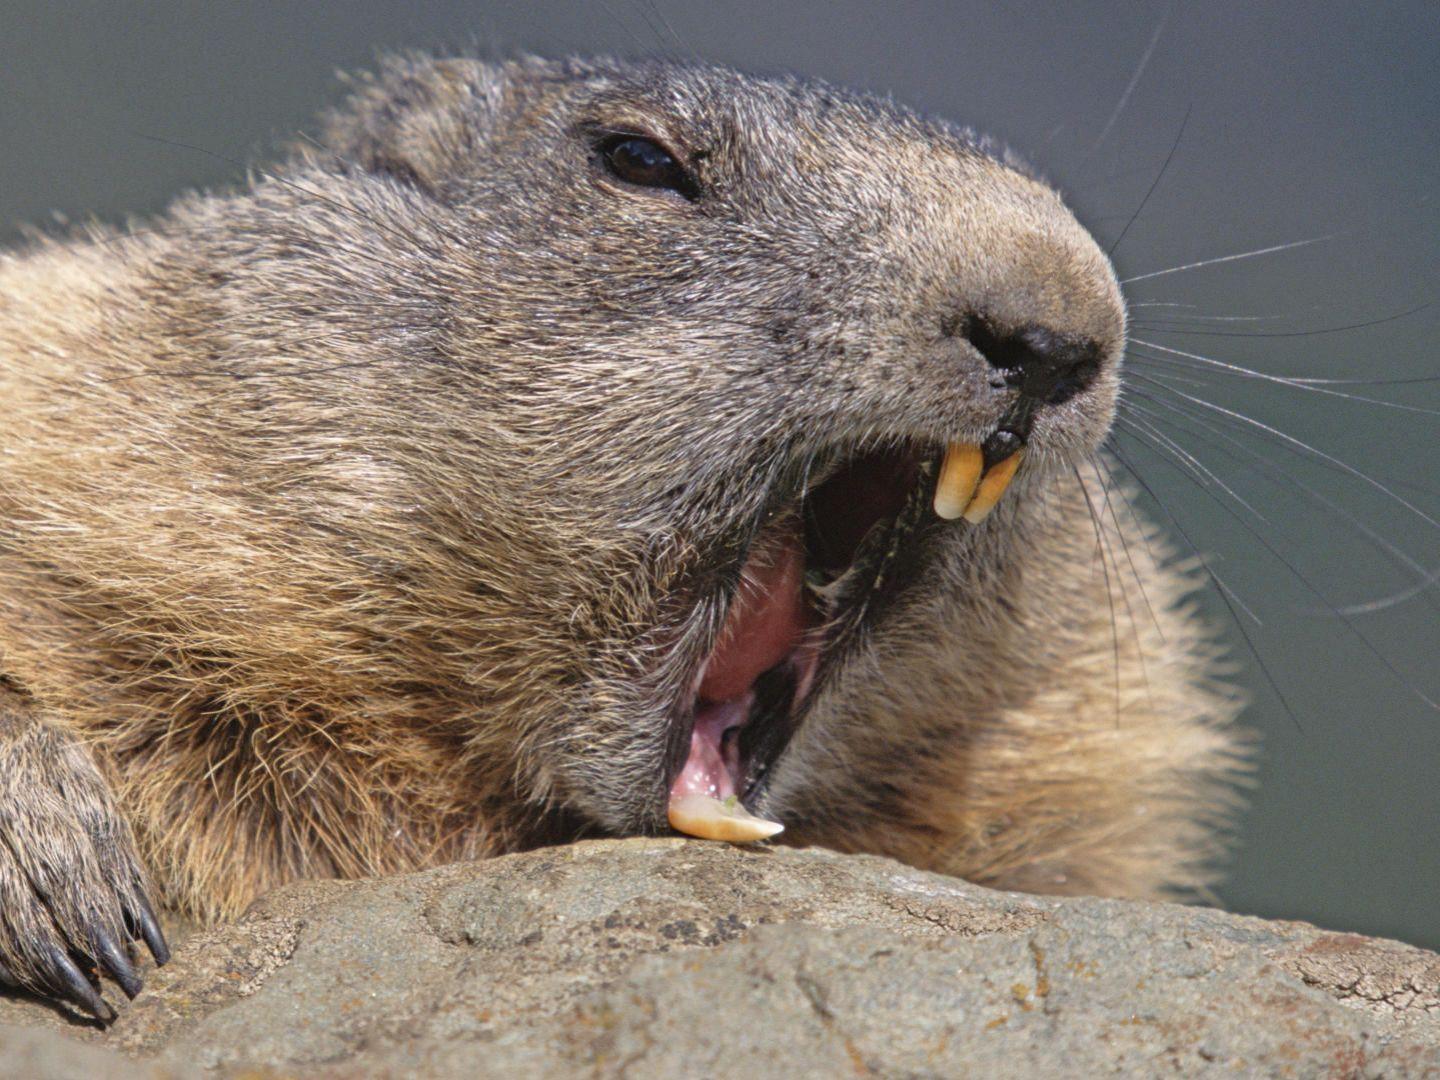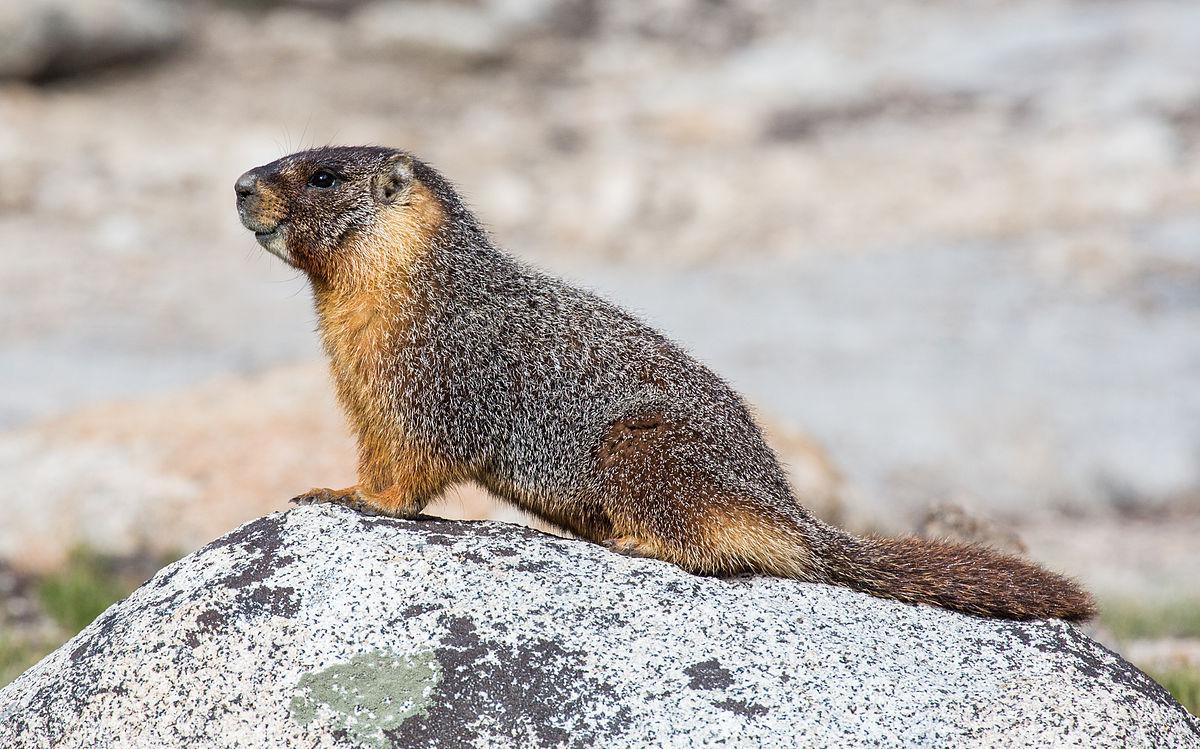The first image is the image on the left, the second image is the image on the right. For the images shown, is this caption "One of the animals is facing towards the left." true? Answer yes or no. Yes. The first image is the image on the left, the second image is the image on the right. Evaluate the accuracy of this statement regarding the images: "A marmot is emerging from a crevice, with rocks above and below the animal.". Is it true? Answer yes or no. No. The first image is the image on the left, the second image is the image on the right. Given the left and right images, does the statement "The rodent in the right image is looking towards the right." hold true? Answer yes or no. No. The first image is the image on the left, the second image is the image on the right. Examine the images to the left and right. Is the description "Two marmots are facing in opposite directions" accurate? Answer yes or no. Yes. 